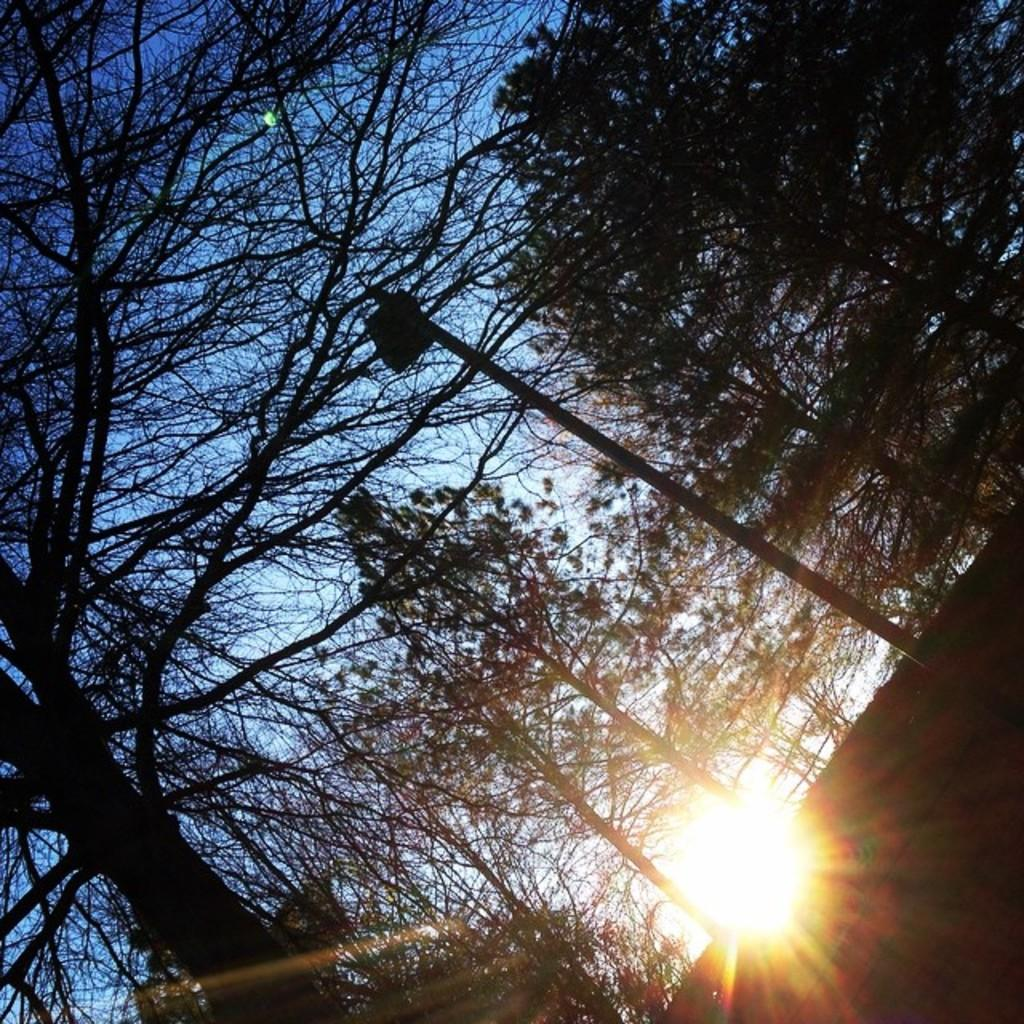What type of vegetation can be seen in the image? There are trees in the image. What is located in the middle of the image? There is a pole in the middle of the image. What is visible in the background of the image? The sky is visible in the background of the image. Can you describe the position of the sun in the image? The sun is present in the sky at the bottom of the image. What type of business is being conducted in the image? There is no indication of any business activity in the image; it primarily features trees, a pole, and the sky. How does the sun affect the digestion of the trees in the image? The image does not show any trees undergoing digestion, nor does it provide information about the sun's effect on their digestion. 